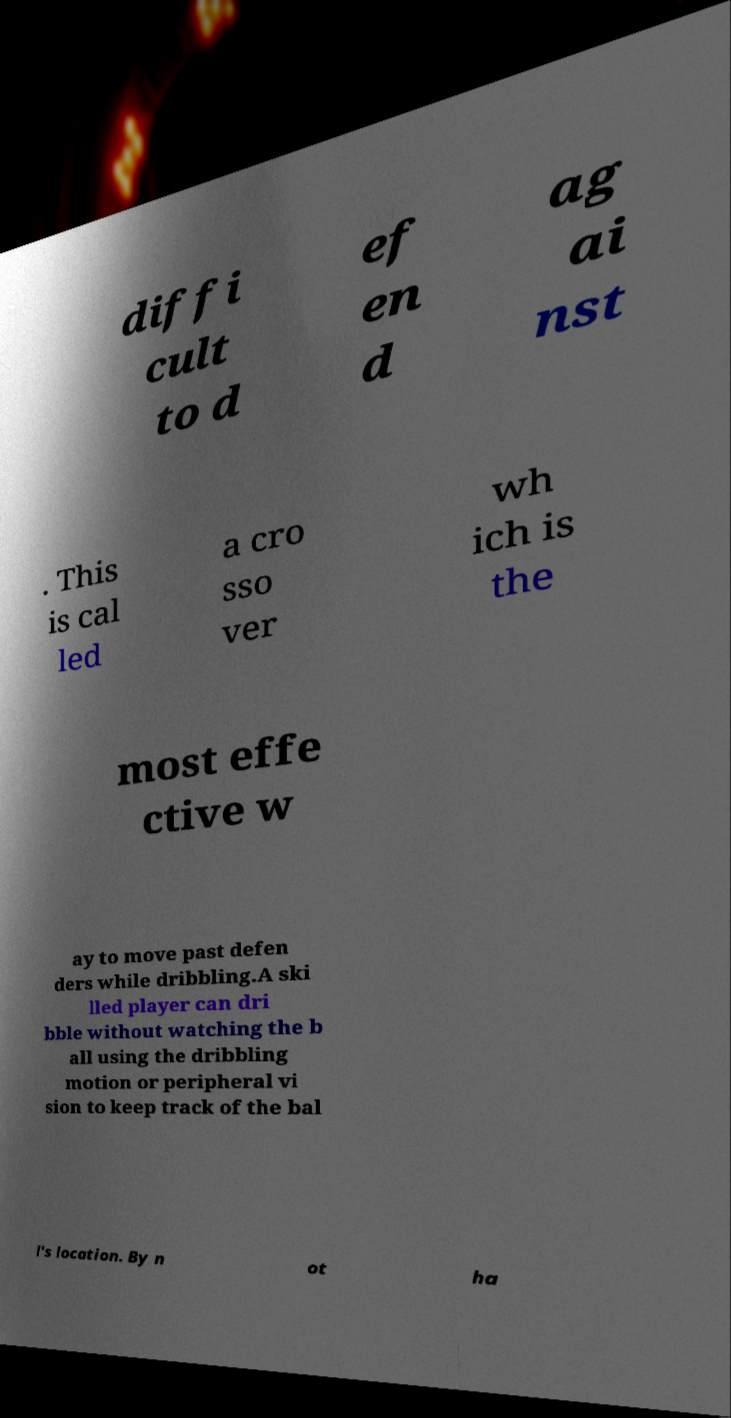What messages or text are displayed in this image? I need them in a readable, typed format. diffi cult to d ef en d ag ai nst . This is cal led a cro sso ver wh ich is the most effe ctive w ay to move past defen ders while dribbling.A ski lled player can dri bble without watching the b all using the dribbling motion or peripheral vi sion to keep track of the bal l's location. By n ot ha 